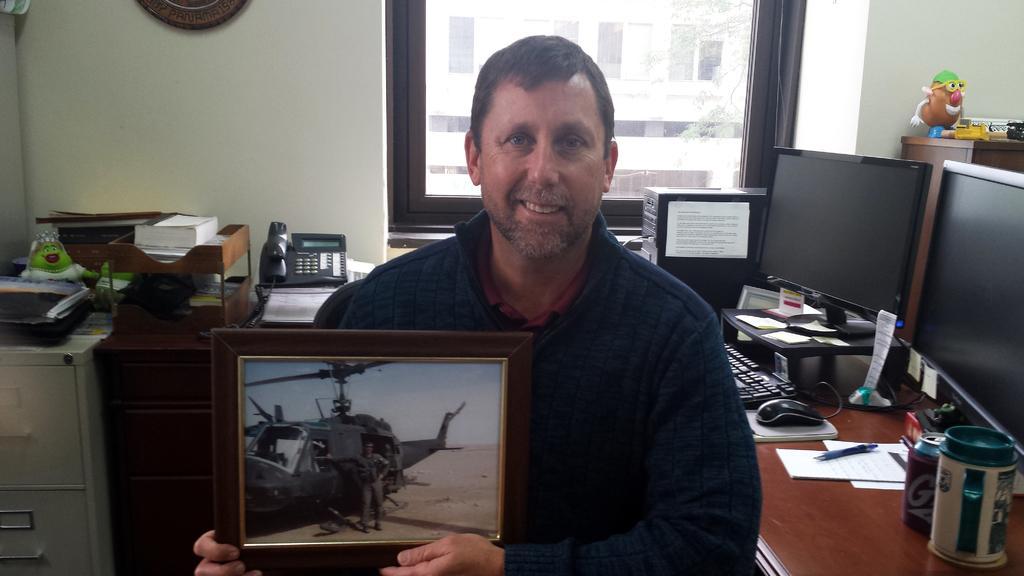In one or two sentences, can you explain what this image depicts? In this picture we can see a person is holding a photo frame. Behind the man there are desks and on the desks there is a mouse, keyboard ,book, papers, pen, monitors, CPU, telephone, a toy and some objects. On the right side of the monitors, it looks like a cabinet and on the cabinet there are toys. Behind the CPU there's a wall with glass window and an object. Behind the window there is a tree and a building. 